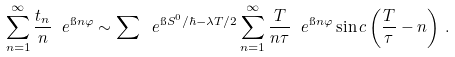Convert formula to latex. <formula><loc_0><loc_0><loc_500><loc_500>\sum _ { n = 1 } ^ { \infty } \frac { t _ { n } } { n } \ e ^ { \i n \varphi } \sim \sum \ e ^ { \i S ^ { 0 } / \hbar { - } \lambda T / 2 } \sum _ { n = 1 } ^ { \infty } \frac { T } { n \tau } \ e ^ { \i n \varphi } \sin c \left ( \frac { T } { \tau } - n \right ) \, .</formula> 